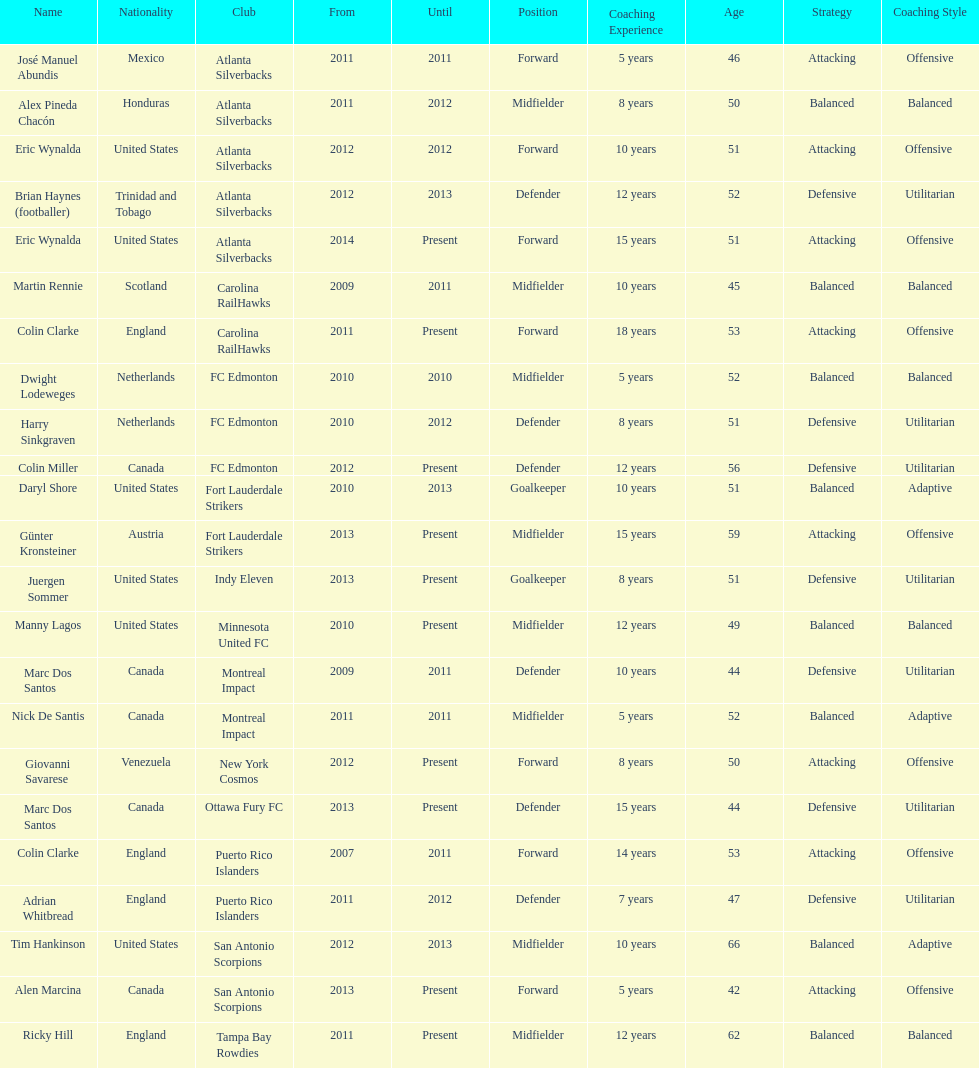How long did colin clarke coach the puerto rico islanders? 4 years. 